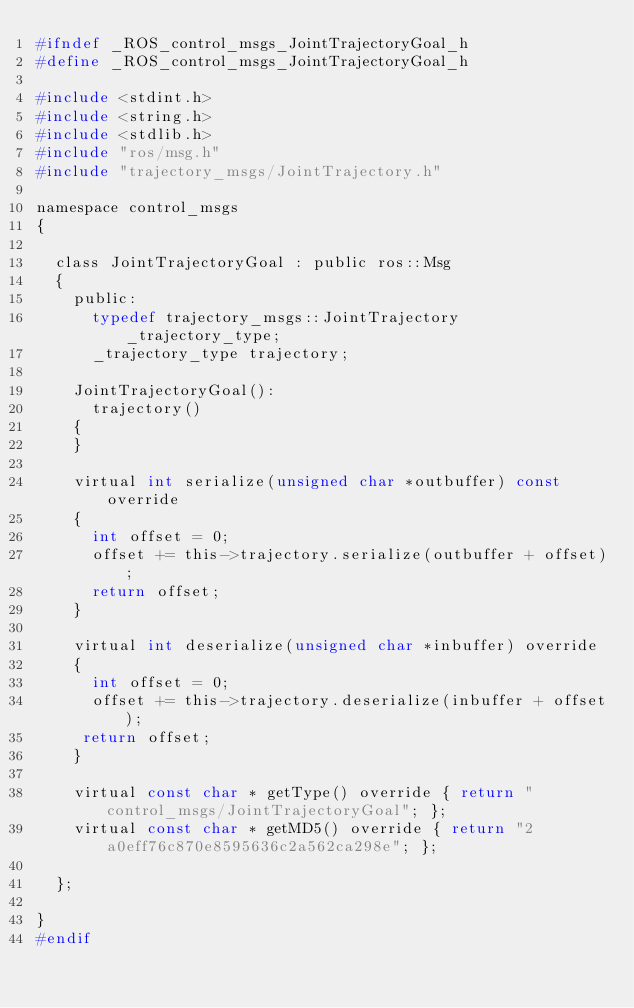Convert code to text. <code><loc_0><loc_0><loc_500><loc_500><_C_>#ifndef _ROS_control_msgs_JointTrajectoryGoal_h
#define _ROS_control_msgs_JointTrajectoryGoal_h

#include <stdint.h>
#include <string.h>
#include <stdlib.h>
#include "ros/msg.h"
#include "trajectory_msgs/JointTrajectory.h"

namespace control_msgs
{

  class JointTrajectoryGoal : public ros::Msg
  {
    public:
      typedef trajectory_msgs::JointTrajectory _trajectory_type;
      _trajectory_type trajectory;

    JointTrajectoryGoal():
      trajectory()
    {
    }

    virtual int serialize(unsigned char *outbuffer) const override
    {
      int offset = 0;
      offset += this->trajectory.serialize(outbuffer + offset);
      return offset;
    }

    virtual int deserialize(unsigned char *inbuffer) override
    {
      int offset = 0;
      offset += this->trajectory.deserialize(inbuffer + offset);
     return offset;
    }

    virtual const char * getType() override { return "control_msgs/JointTrajectoryGoal"; };
    virtual const char * getMD5() override { return "2a0eff76c870e8595636c2a562ca298e"; };

  };

}
#endif
</code> 